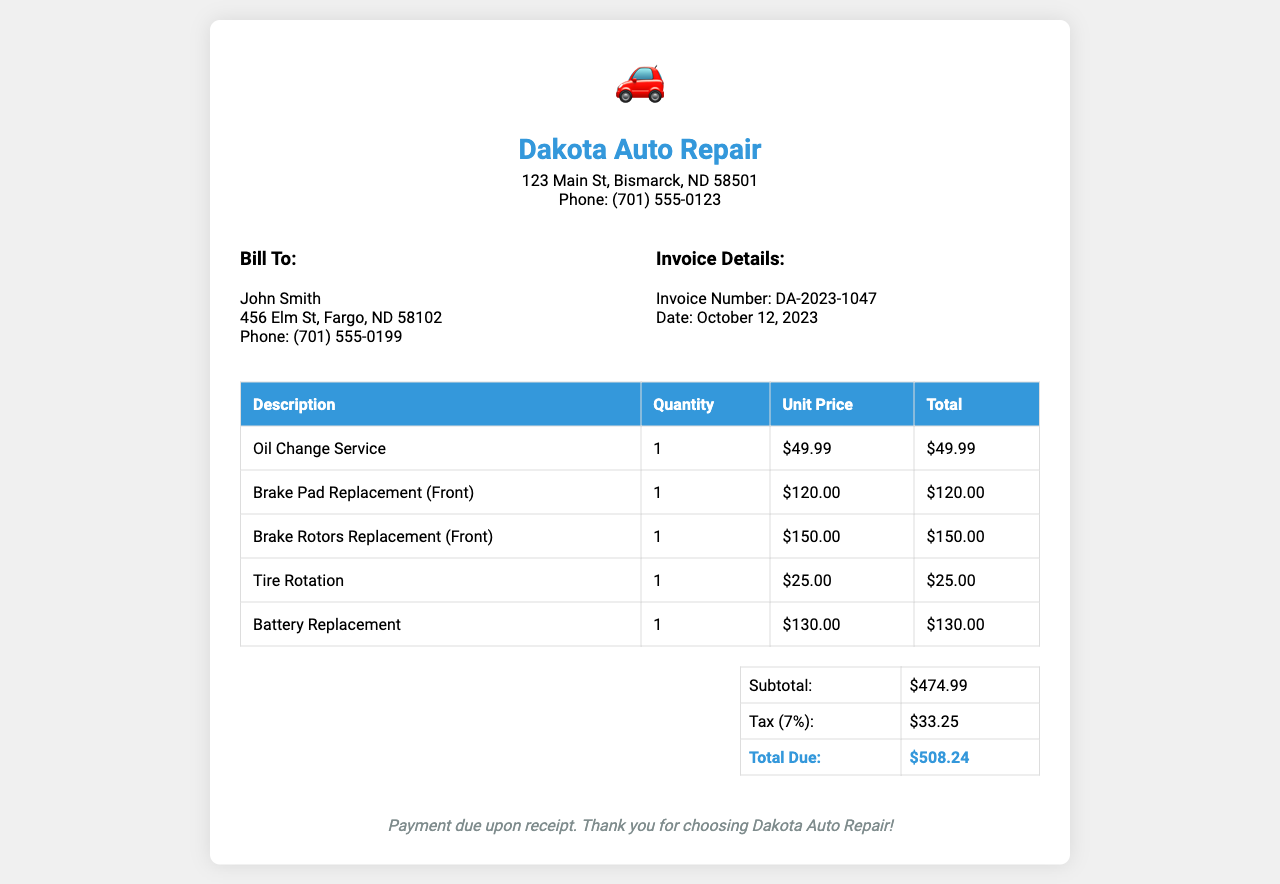What is the invoice number? The invoice number is specified in the document and is a unique identifier for this transaction.
Answer: DA-2023-1047 What is the total due amount? The total due amount is the final amount payable, calculated with the subtotal and tax included.
Answer: $508.24 Who is the customer? The customer’s name is present in the document under the billing section.
Answer: John Smith What is the date of the invoice? The date is mentioned in the invoice details section and indicates when the invoice was issued.
Answer: October 12, 2023 What service was charged the most? To determine the highest cost service, we look at the unit price and total for each service listed.
Answer: Brake Rotors Replacement (Front) What is the subtotal amount? The subtotal is found right before the tax calculation and represents the total of all services before tax.
Answer: $474.99 What percentage was charged for tax? The tax rate is mentioned in the document and represents the percentage calculated on the subtotal.
Answer: 7% How many services were provided? The total number of services can be counted from the list in the invoice.
Answer: 5 Where is Dakota Auto Repair located? The address is provided in the header of the invoice, indicating where the shop is located.
Answer: 123 Main St, Bismarck, ND 58501 